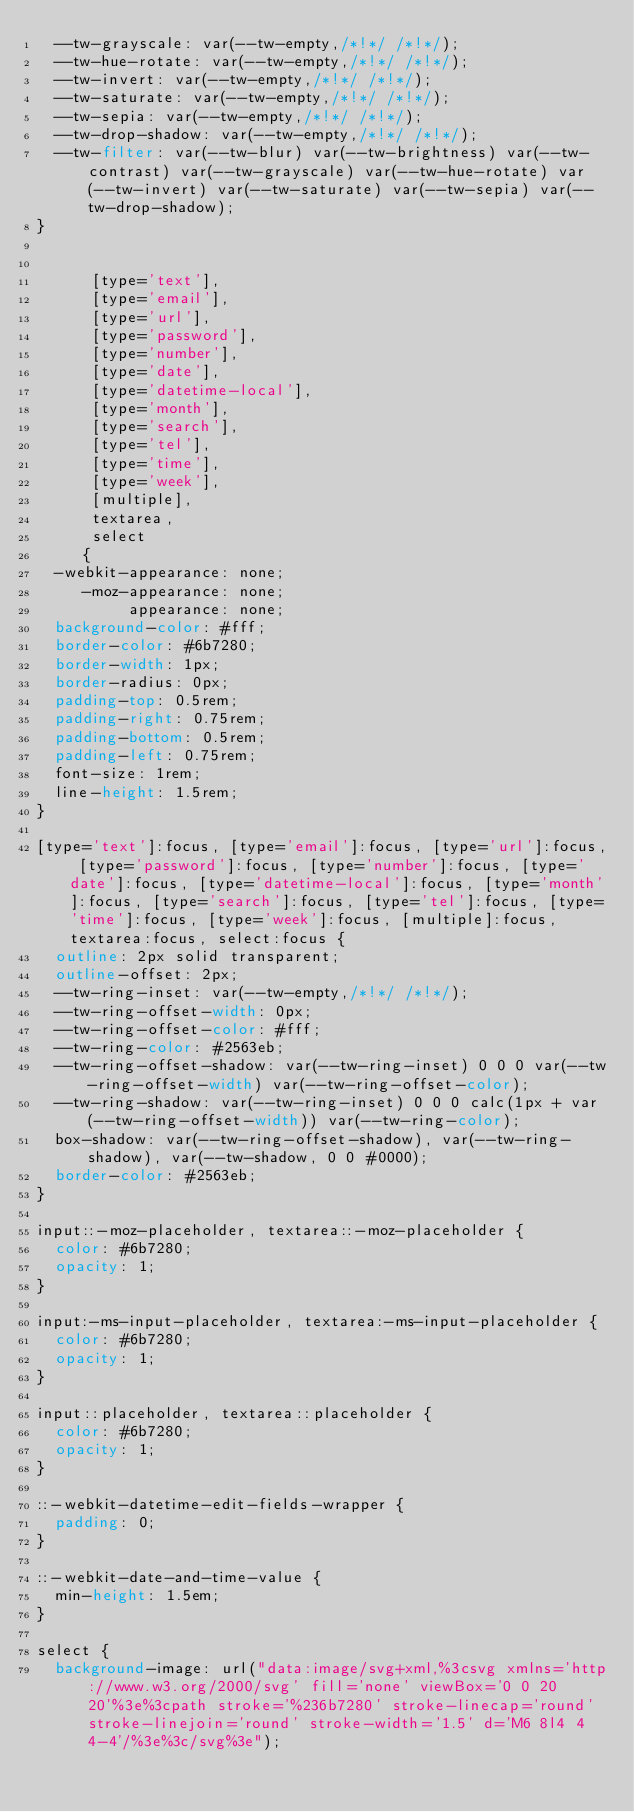Convert code to text. <code><loc_0><loc_0><loc_500><loc_500><_CSS_>	--tw-grayscale: var(--tw-empty,/*!*/ /*!*/);
	--tw-hue-rotate: var(--tw-empty,/*!*/ /*!*/);
	--tw-invert: var(--tw-empty,/*!*/ /*!*/);
	--tw-saturate: var(--tw-empty,/*!*/ /*!*/);
	--tw-sepia: var(--tw-empty,/*!*/ /*!*/);
	--tw-drop-shadow: var(--tw-empty,/*!*/ /*!*/);
	--tw-filter: var(--tw-blur) var(--tw-brightness) var(--tw-contrast) var(--tw-grayscale) var(--tw-hue-rotate) var(--tw-invert) var(--tw-saturate) var(--tw-sepia) var(--tw-drop-shadow);
}


      [type='text'],
      [type='email'],
      [type='url'],
      [type='password'],
      [type='number'],
      [type='date'],
      [type='datetime-local'],
      [type='month'],
      [type='search'],
      [type='tel'],
      [type='time'],
      [type='week'],
      [multiple],
      textarea,
      select
     {
	-webkit-appearance: none;
	   -moz-appearance: none;
	        appearance: none;
	background-color: #fff;
	border-color: #6b7280;
	border-width: 1px;
	border-radius: 0px;
	padding-top: 0.5rem;
	padding-right: 0.75rem;
	padding-bottom: 0.5rem;
	padding-left: 0.75rem;
	font-size: 1rem;
	line-height: 1.5rem;
}

[type='text']:focus, [type='email']:focus, [type='url']:focus, [type='password']:focus, [type='number']:focus, [type='date']:focus, [type='datetime-local']:focus, [type='month']:focus, [type='search']:focus, [type='tel']:focus, [type='time']:focus, [type='week']:focus, [multiple]:focus, textarea:focus, select:focus {
	outline: 2px solid transparent;
	outline-offset: 2px;
	--tw-ring-inset: var(--tw-empty,/*!*/ /*!*/);
	--tw-ring-offset-width: 0px;
	--tw-ring-offset-color: #fff;
	--tw-ring-color: #2563eb;
	--tw-ring-offset-shadow: var(--tw-ring-inset) 0 0 0 var(--tw-ring-offset-width) var(--tw-ring-offset-color);
	--tw-ring-shadow: var(--tw-ring-inset) 0 0 0 calc(1px + var(--tw-ring-offset-width)) var(--tw-ring-color);
	box-shadow: var(--tw-ring-offset-shadow), var(--tw-ring-shadow), var(--tw-shadow, 0 0 #0000);
	border-color: #2563eb;
}

input::-moz-placeholder, textarea::-moz-placeholder {
	color: #6b7280;
	opacity: 1;
}

input:-ms-input-placeholder, textarea:-ms-input-placeholder {
	color: #6b7280;
	opacity: 1;
}

input::placeholder, textarea::placeholder {
	color: #6b7280;
	opacity: 1;
}

::-webkit-datetime-edit-fields-wrapper {
	padding: 0;
}

::-webkit-date-and-time-value {
	min-height: 1.5em;
}

select {
	background-image: url("data:image/svg+xml,%3csvg xmlns='http://www.w3.org/2000/svg' fill='none' viewBox='0 0 20 20'%3e%3cpath stroke='%236b7280' stroke-linecap='round' stroke-linejoin='round' stroke-width='1.5' d='M6 8l4 4 4-4'/%3e%3c/svg%3e");</code> 